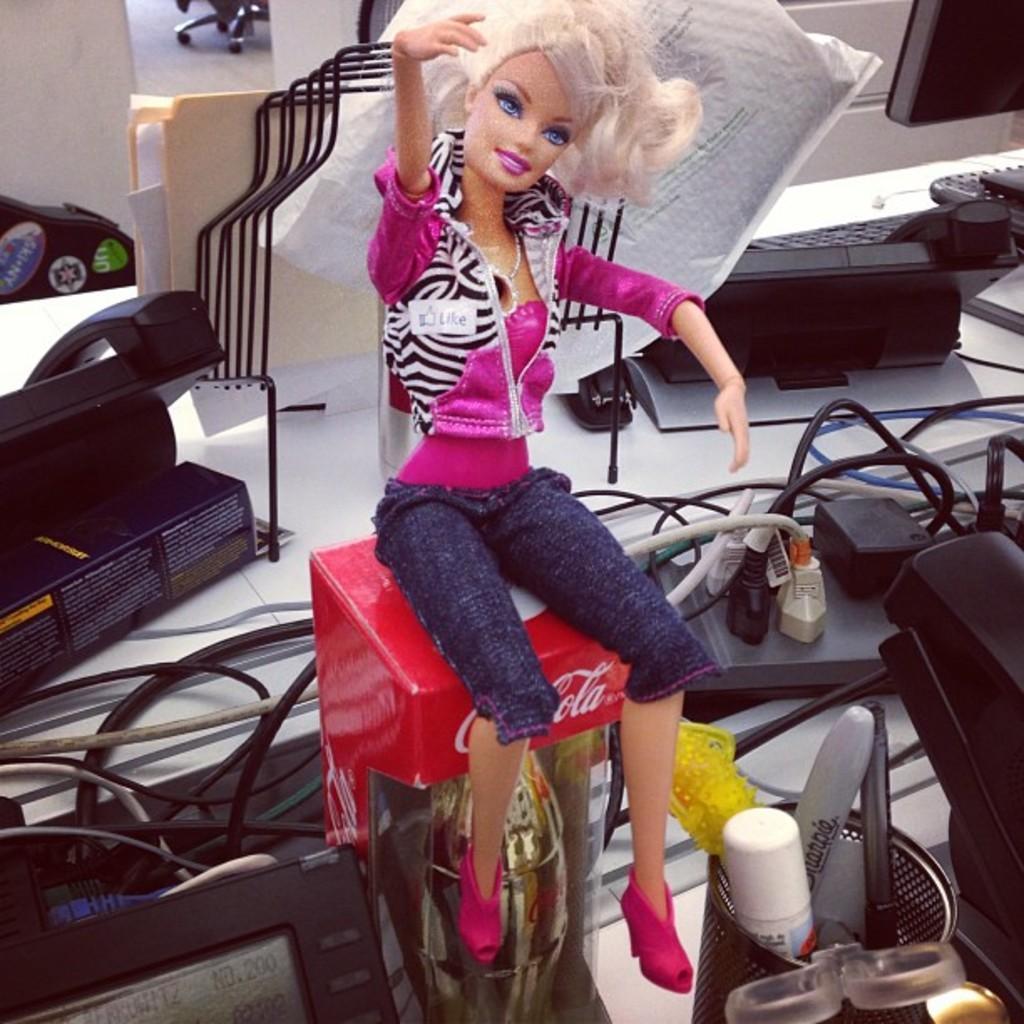Could you give a brief overview of what you see in this image? In this image we can see a barbie doll which is on the cake box there are some junction boxes, telephones, monitor, files and some other items on the desk which is of white color. 